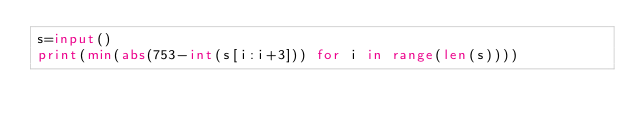Convert code to text. <code><loc_0><loc_0><loc_500><loc_500><_Python_>s=input()
print(min(abs(753-int(s[i:i+3])) for i in range(len(s))))
</code> 